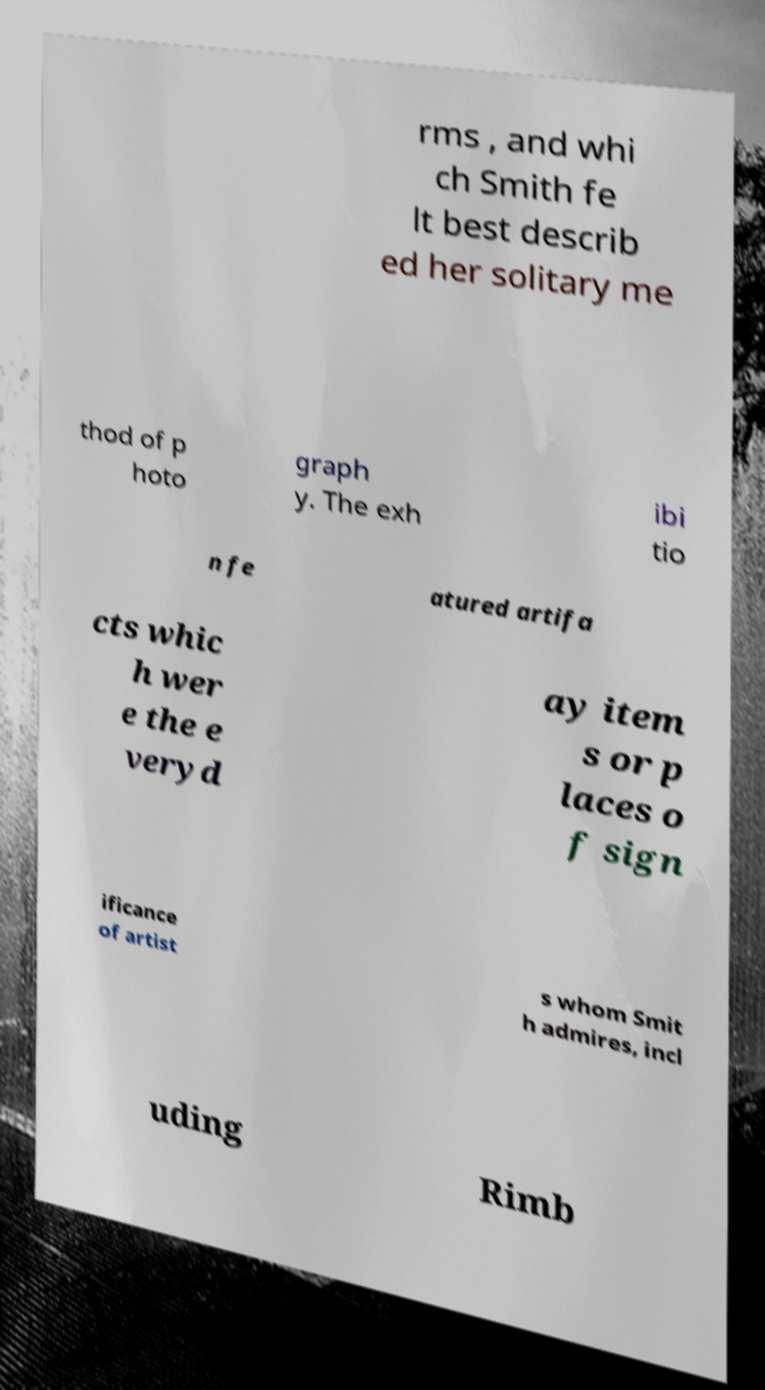I need the written content from this picture converted into text. Can you do that? rms , and whi ch Smith fe lt best describ ed her solitary me thod of p hoto graph y. The exh ibi tio n fe atured artifa cts whic h wer e the e veryd ay item s or p laces o f sign ificance of artist s whom Smit h admires, incl uding Rimb 